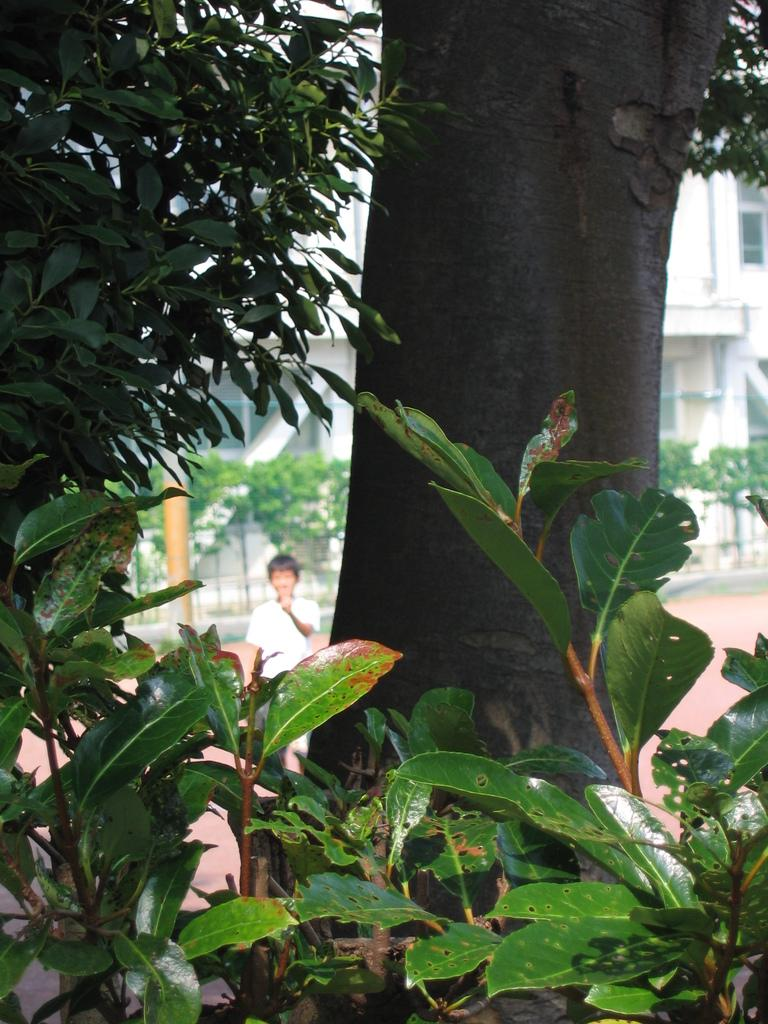What type of vegetation can be seen in the image? There are plants, a tree trunk, and trees visible in the image. Can you describe the background of the image? In the background, there is a person visible, along with a walkway, a pole, plants, and a building. What arithmetic problem is being solved by the plants in the image? There is no arithmetic problem being solved by the plants in the image, as plants do not have the ability to perform arithmetic. 